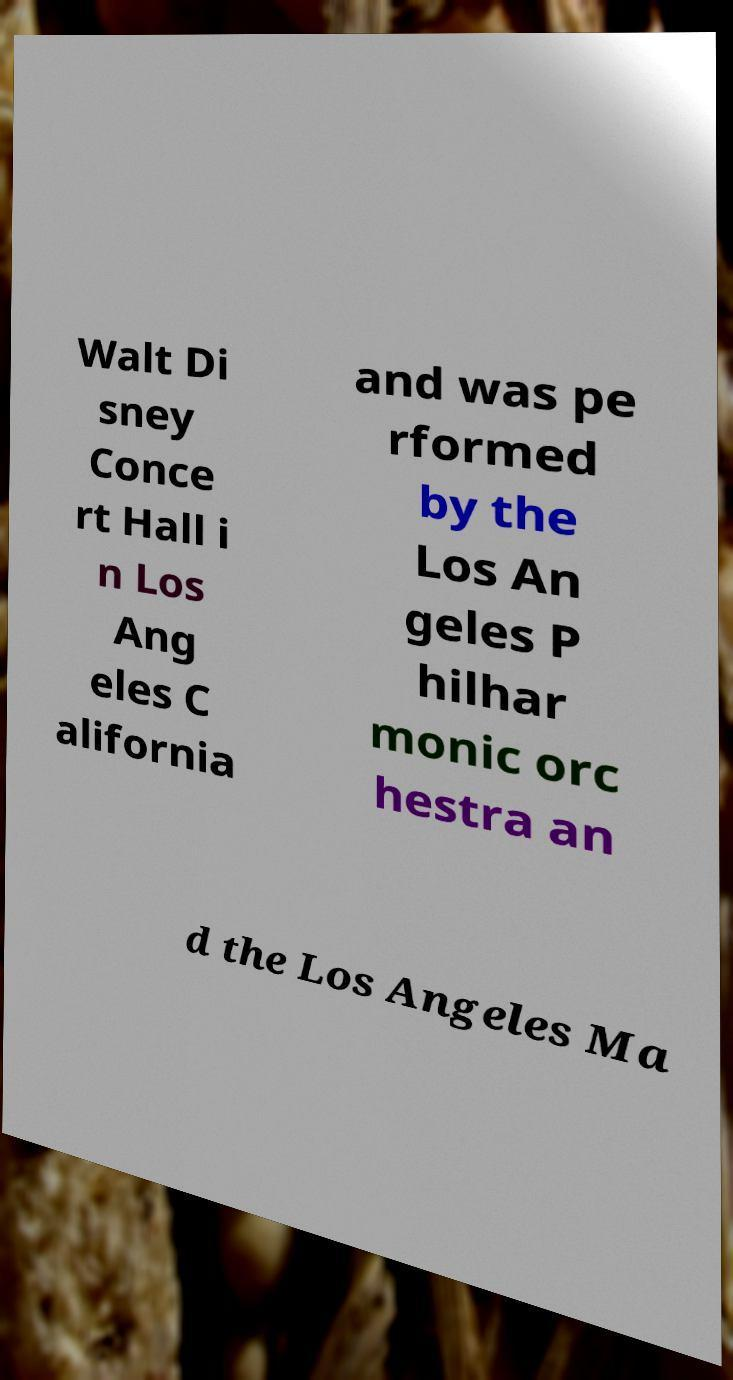For documentation purposes, I need the text within this image transcribed. Could you provide that? Walt Di sney Conce rt Hall i n Los Ang eles C alifornia and was pe rformed by the Los An geles P hilhar monic orc hestra an d the Los Angeles Ma 